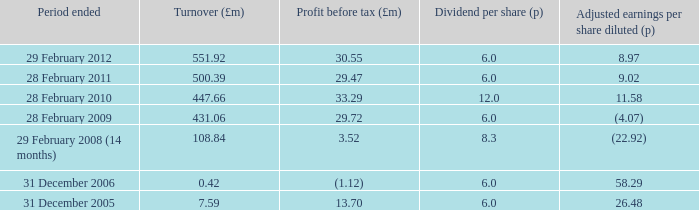What was the profit before tax when the turnover was 431.06? 29.72. 